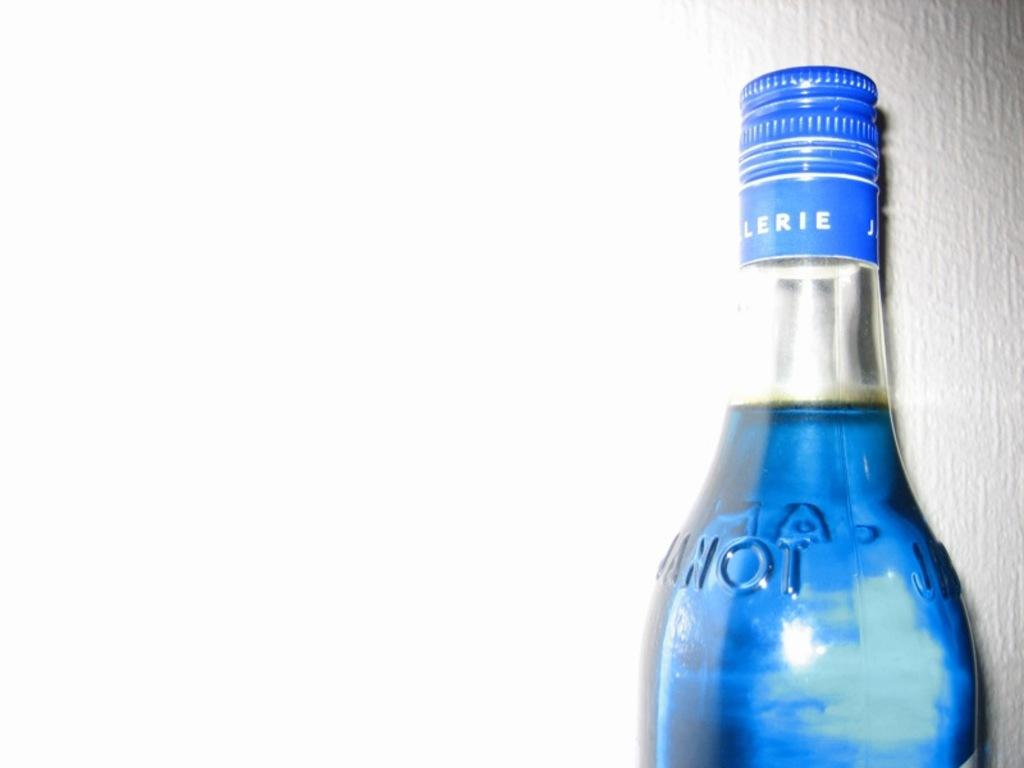<image>
Share a concise interpretation of the image provided. Blue bottle with a top that says "LERIE". 